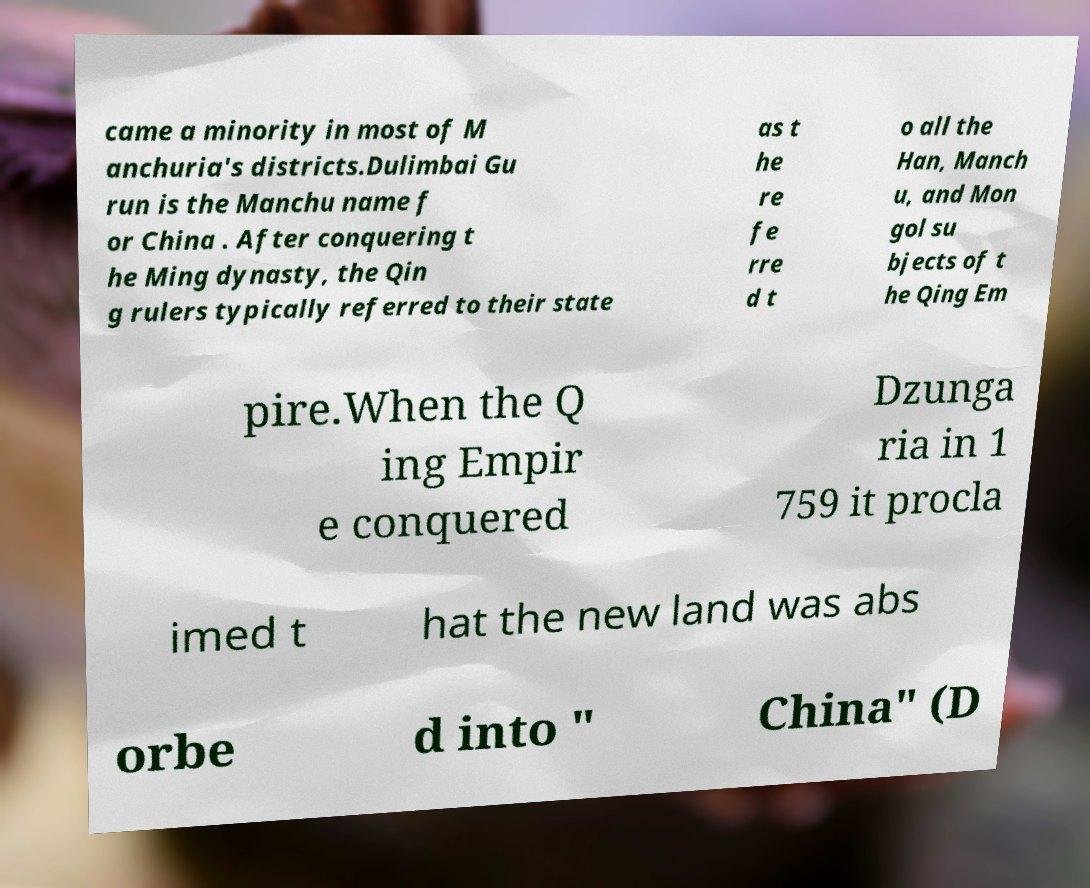There's text embedded in this image that I need extracted. Can you transcribe it verbatim? came a minority in most of M anchuria's districts.Dulimbai Gu run is the Manchu name f or China . After conquering t he Ming dynasty, the Qin g rulers typically referred to their state as t he re fe rre d t o all the Han, Manch u, and Mon gol su bjects of t he Qing Em pire.When the Q ing Empir e conquered Dzunga ria in 1 759 it procla imed t hat the new land was abs orbe d into " China" (D 